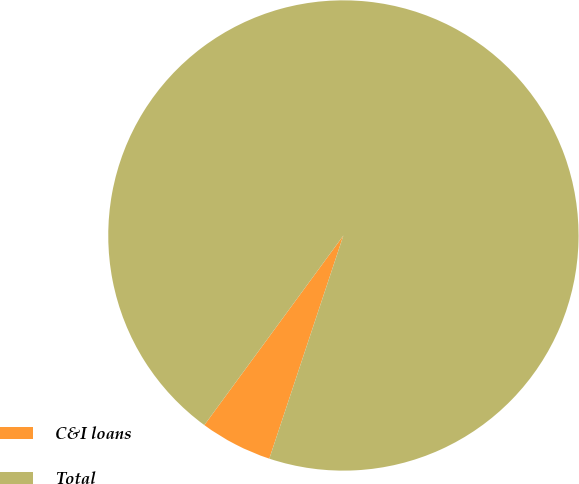Convert chart to OTSL. <chart><loc_0><loc_0><loc_500><loc_500><pie_chart><fcel>C&I loans<fcel>Total<nl><fcel>4.97%<fcel>95.03%<nl></chart> 